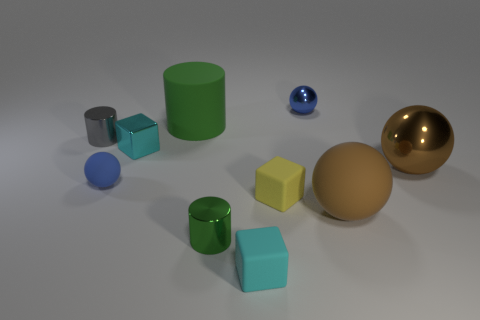There is a brown metal sphere; how many balls are behind it?
Keep it short and to the point. 1. There is a matte sphere that is in front of the tiny rubber thing that is on the right side of the tiny cyan thing to the right of the small green object; what color is it?
Provide a succinct answer. Brown. There is a tiny shiny cylinder behind the large brown matte object; does it have the same color as the big rubber thing to the left of the small cyan matte block?
Provide a short and direct response. No. There is a big matte object that is behind the large brown ball that is in front of the small yellow block; what is its shape?
Ensure brevity in your answer.  Cylinder. Are there any metal balls of the same size as the blue metallic object?
Your answer should be very brief. No. How many gray shiny things have the same shape as the small blue matte thing?
Keep it short and to the point. 0. Are there the same number of metal objects behind the tiny blue metal ball and big green matte cylinders that are to the right of the cyan matte thing?
Your answer should be very brief. Yes. Are any large brown matte blocks visible?
Keep it short and to the point. No. There is a rubber sphere left of the cube right of the small cyan object in front of the big metal ball; what size is it?
Your answer should be compact. Small. There is a gray object that is the same size as the yellow matte thing; what is its shape?
Keep it short and to the point. Cylinder. 